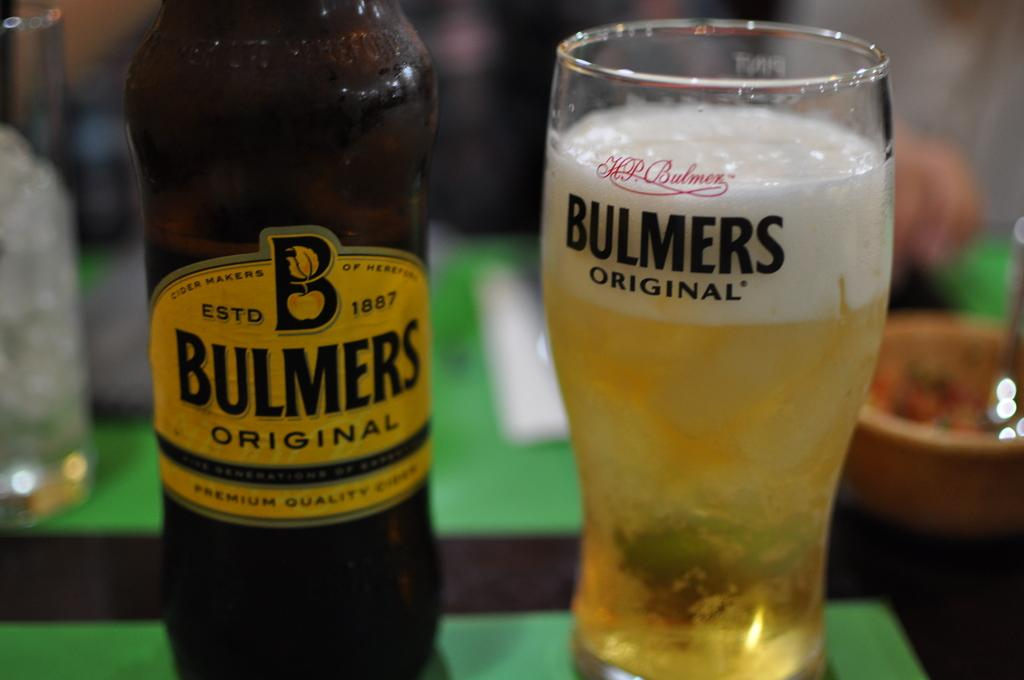<image>
Render a clear and concise summary of the photo. A bottle of Bulmers Original beer sits next to a glass with the same brand on it. 